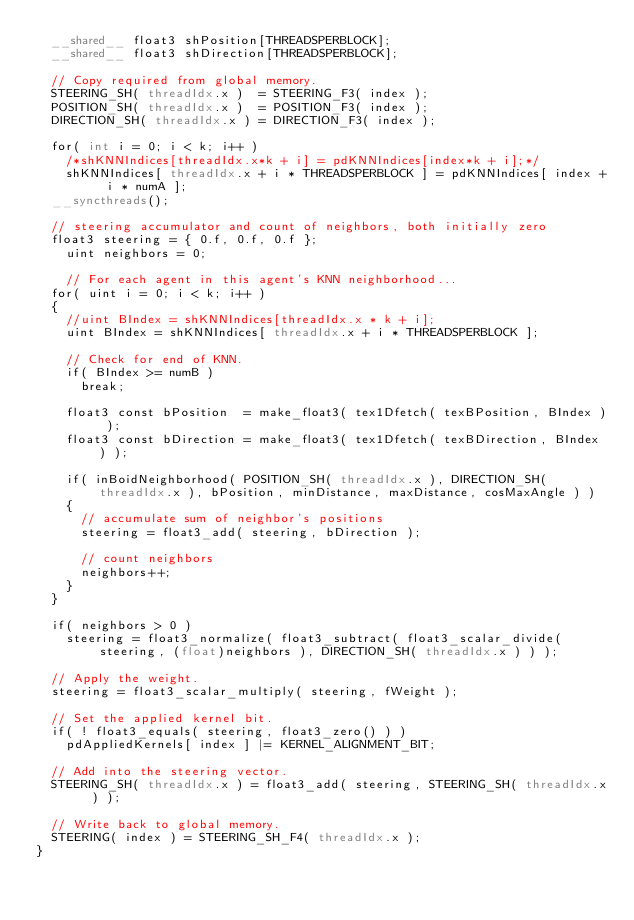<code> <loc_0><loc_0><loc_500><loc_500><_Cuda_>	__shared__ float3 shPosition[THREADSPERBLOCK];
	__shared__ float3 shDirection[THREADSPERBLOCK];

	// Copy required from global memory.
	STEERING_SH( threadIdx.x )	= STEERING_F3( index );
	POSITION_SH( threadIdx.x )	= POSITION_F3( index );
	DIRECTION_SH( threadIdx.x )	= DIRECTION_F3( index );

	for( int i = 0; i < k; i++ )
		/*shKNNIndices[threadIdx.x*k + i] = pdKNNIndices[index*k + i];*/
		shKNNIndices[ threadIdx.x + i * THREADSPERBLOCK ] = pdKNNIndices[ index + i * numA ];
	__syncthreads();

	// steering accumulator and count of neighbors, both initially zero
	float3 steering = { 0.f, 0.f, 0.f };
    uint neighbors = 0;

    // For each agent in this agent's KNN neighborhood...
	for( uint i = 0; i < k; i++ )
	{
		//uint BIndex = shKNNIndices[threadIdx.x * k + i];
		uint BIndex = shKNNIndices[ threadIdx.x + i * THREADSPERBLOCK ];

		// Check for end of KNN.
		if( BIndex >= numB )
			break;

		float3 const bPosition	= make_float3( tex1Dfetch( texBPosition, BIndex ) );
		float3 const bDirection	= make_float3( tex1Dfetch( texBDirection, BIndex ) );

		if( inBoidNeighborhood( POSITION_SH( threadIdx.x ), DIRECTION_SH( threadIdx.x ), bPosition, minDistance, maxDistance, cosMaxAngle ) )
		{
			// accumulate sum of neighbor's positions
			steering = float3_add( steering, bDirection );

			// count neighbors
			neighbors++;
		}
	}

	if( neighbors > 0 )
		steering = float3_normalize( float3_subtract( float3_scalar_divide( steering, (float)neighbors ), DIRECTION_SH( threadIdx.x ) ) );

	// Apply the weight.
	steering = float3_scalar_multiply( steering, fWeight );

	// Set the applied kernel bit.
	if( ! float3_equals( steering, float3_zero() ) )
		pdAppliedKernels[ index ] |= KERNEL_ALIGNMENT_BIT;

	// Add into the steering vector.
	STEERING_SH( threadIdx.x ) = float3_add( steering, STEERING_SH( threadIdx.x ) );

	// Write back to global memory.
	STEERING( index ) = STEERING_SH_F4( threadIdx.x );
}
</code> 